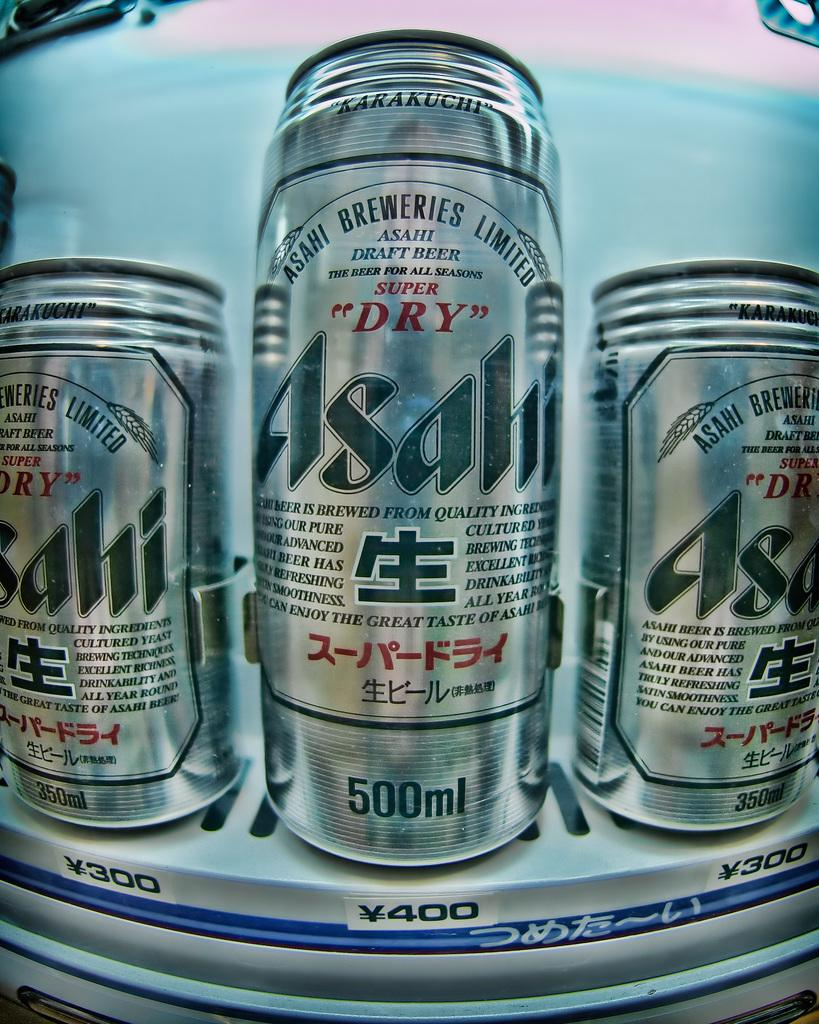<image>
Offer a succinct explanation of the picture presented. Three cans in various sizes of Asali Super Dry inside a foreign vending machine. 